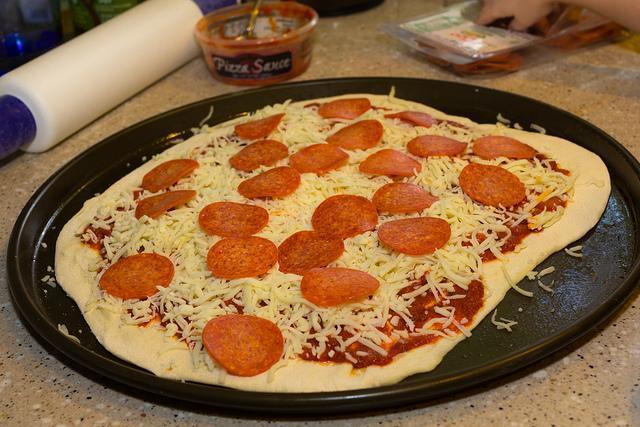How many people are visible?
Give a very brief answer. 1. How many kites are flying?
Give a very brief answer. 0. 